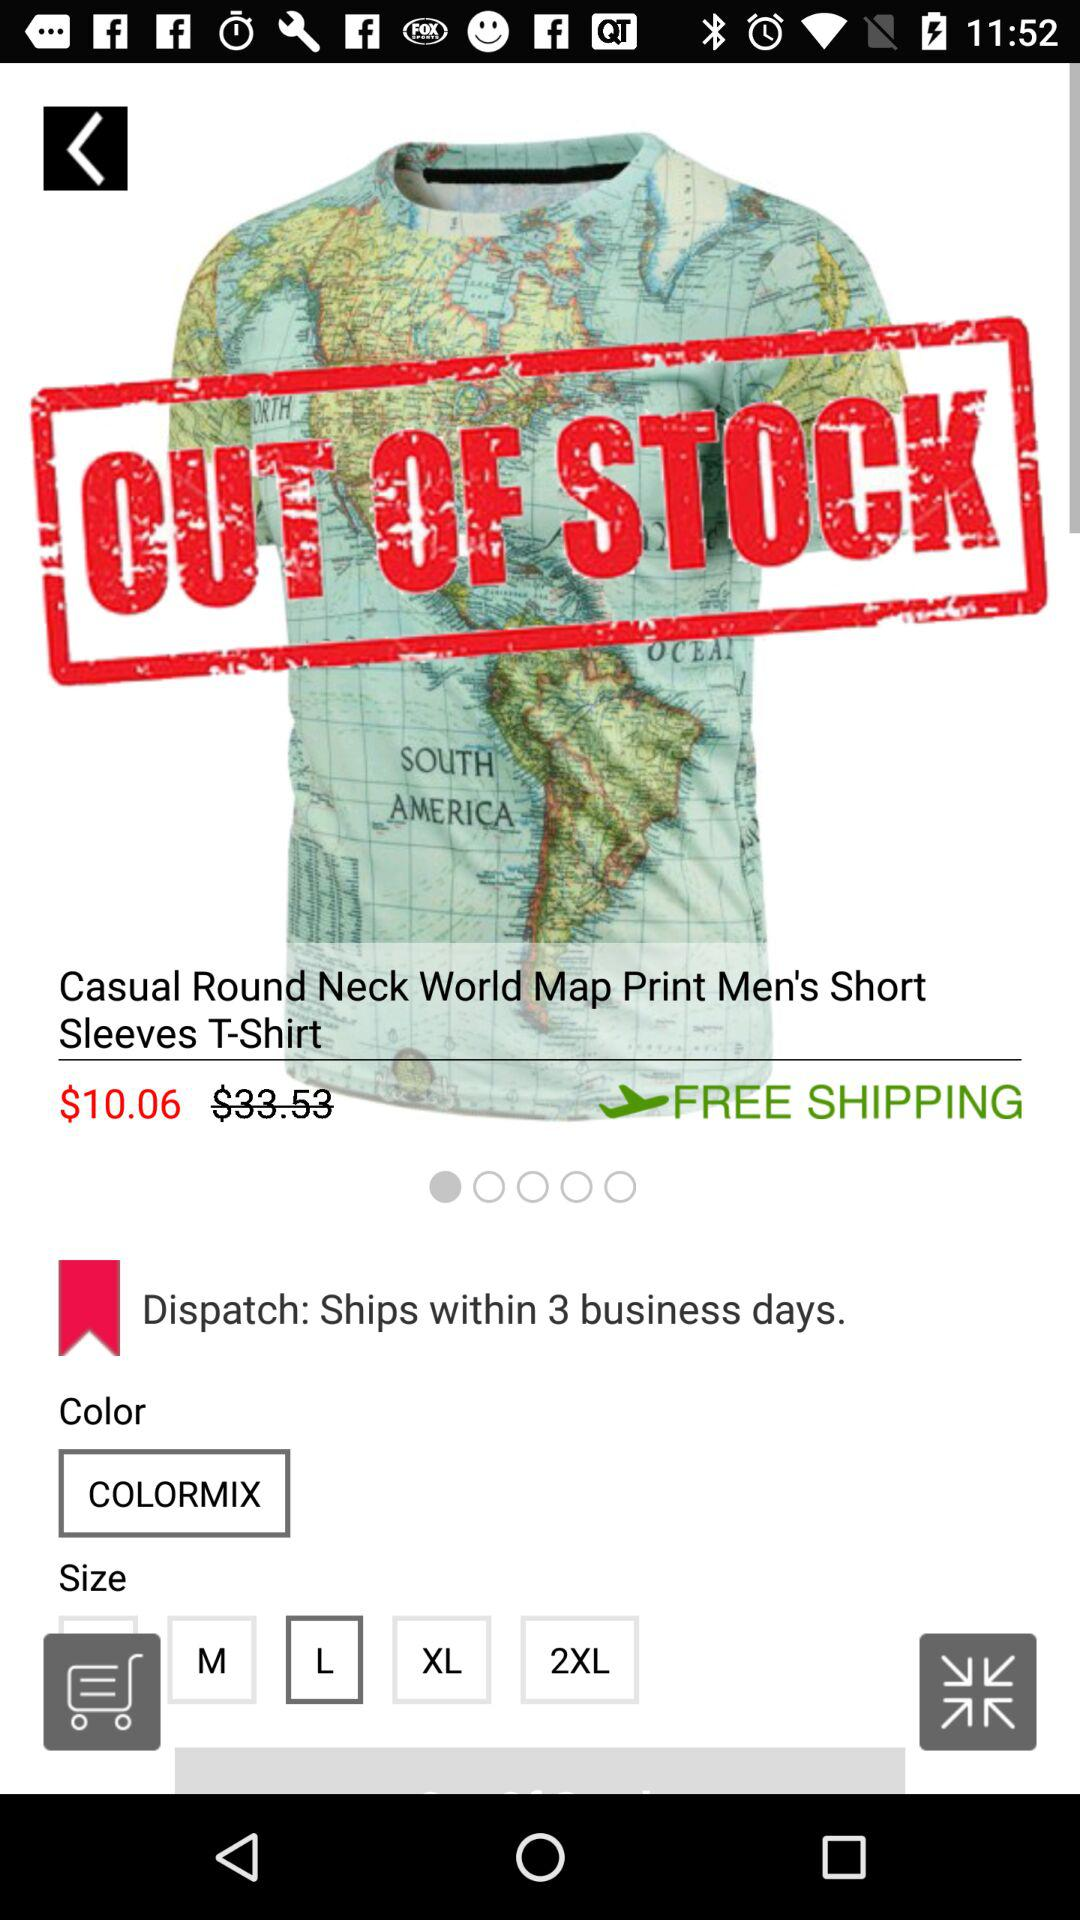Which color is selected? The selected color is "COLORMIX". 